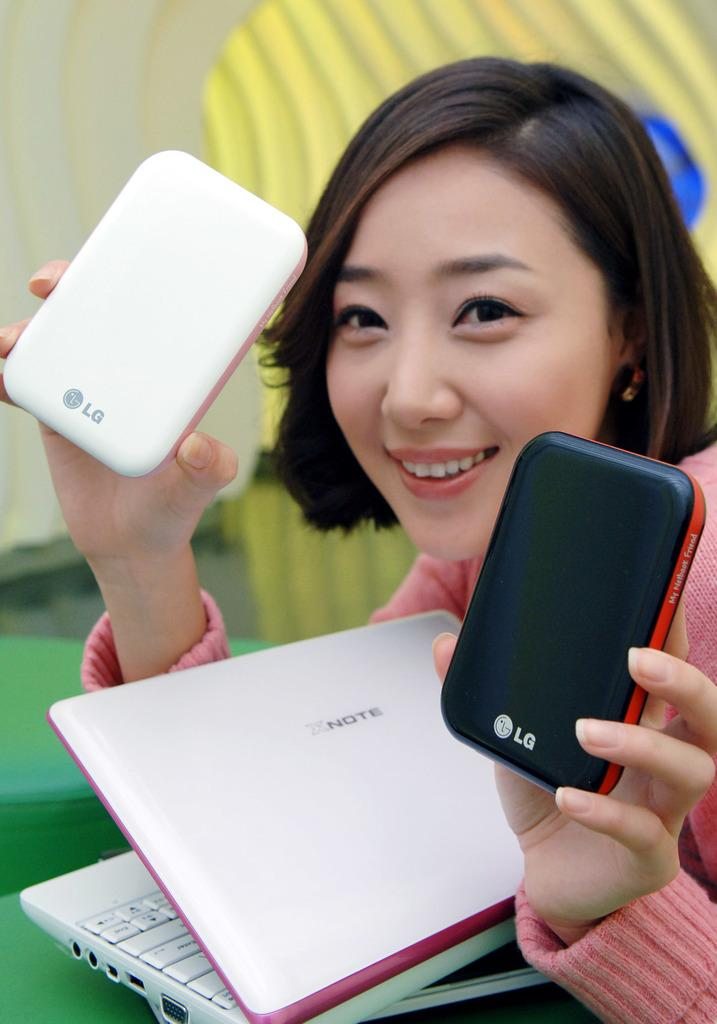<image>
Summarize the visual content of the image. A young woman in a pink sweater holds an electronic device in each hand, one black and one white, each bearing the LG product symbol. 